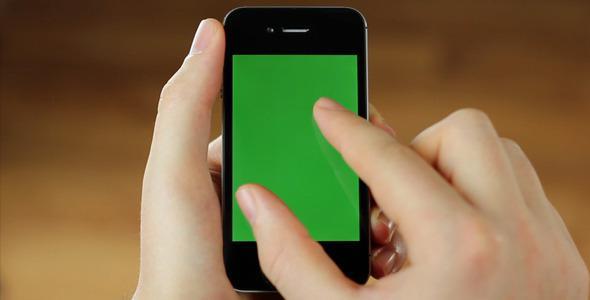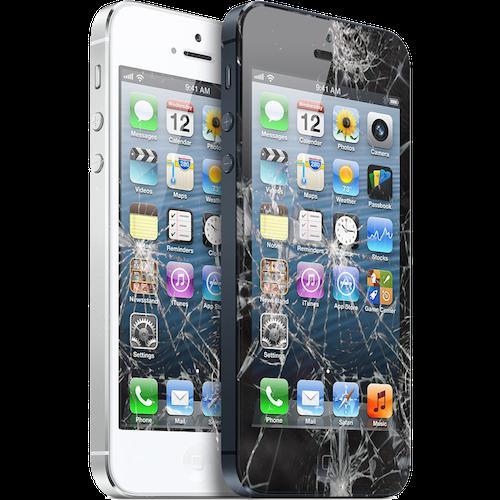The first image is the image on the left, the second image is the image on the right. Given the left and right images, does the statement "The right image contains a human hand holding a smart phone." hold true? Answer yes or no. No. The first image is the image on the left, the second image is the image on the right. Evaluate the accuracy of this statement regarding the images: "There are exactly two phones in total.". Is it true? Answer yes or no. No. 